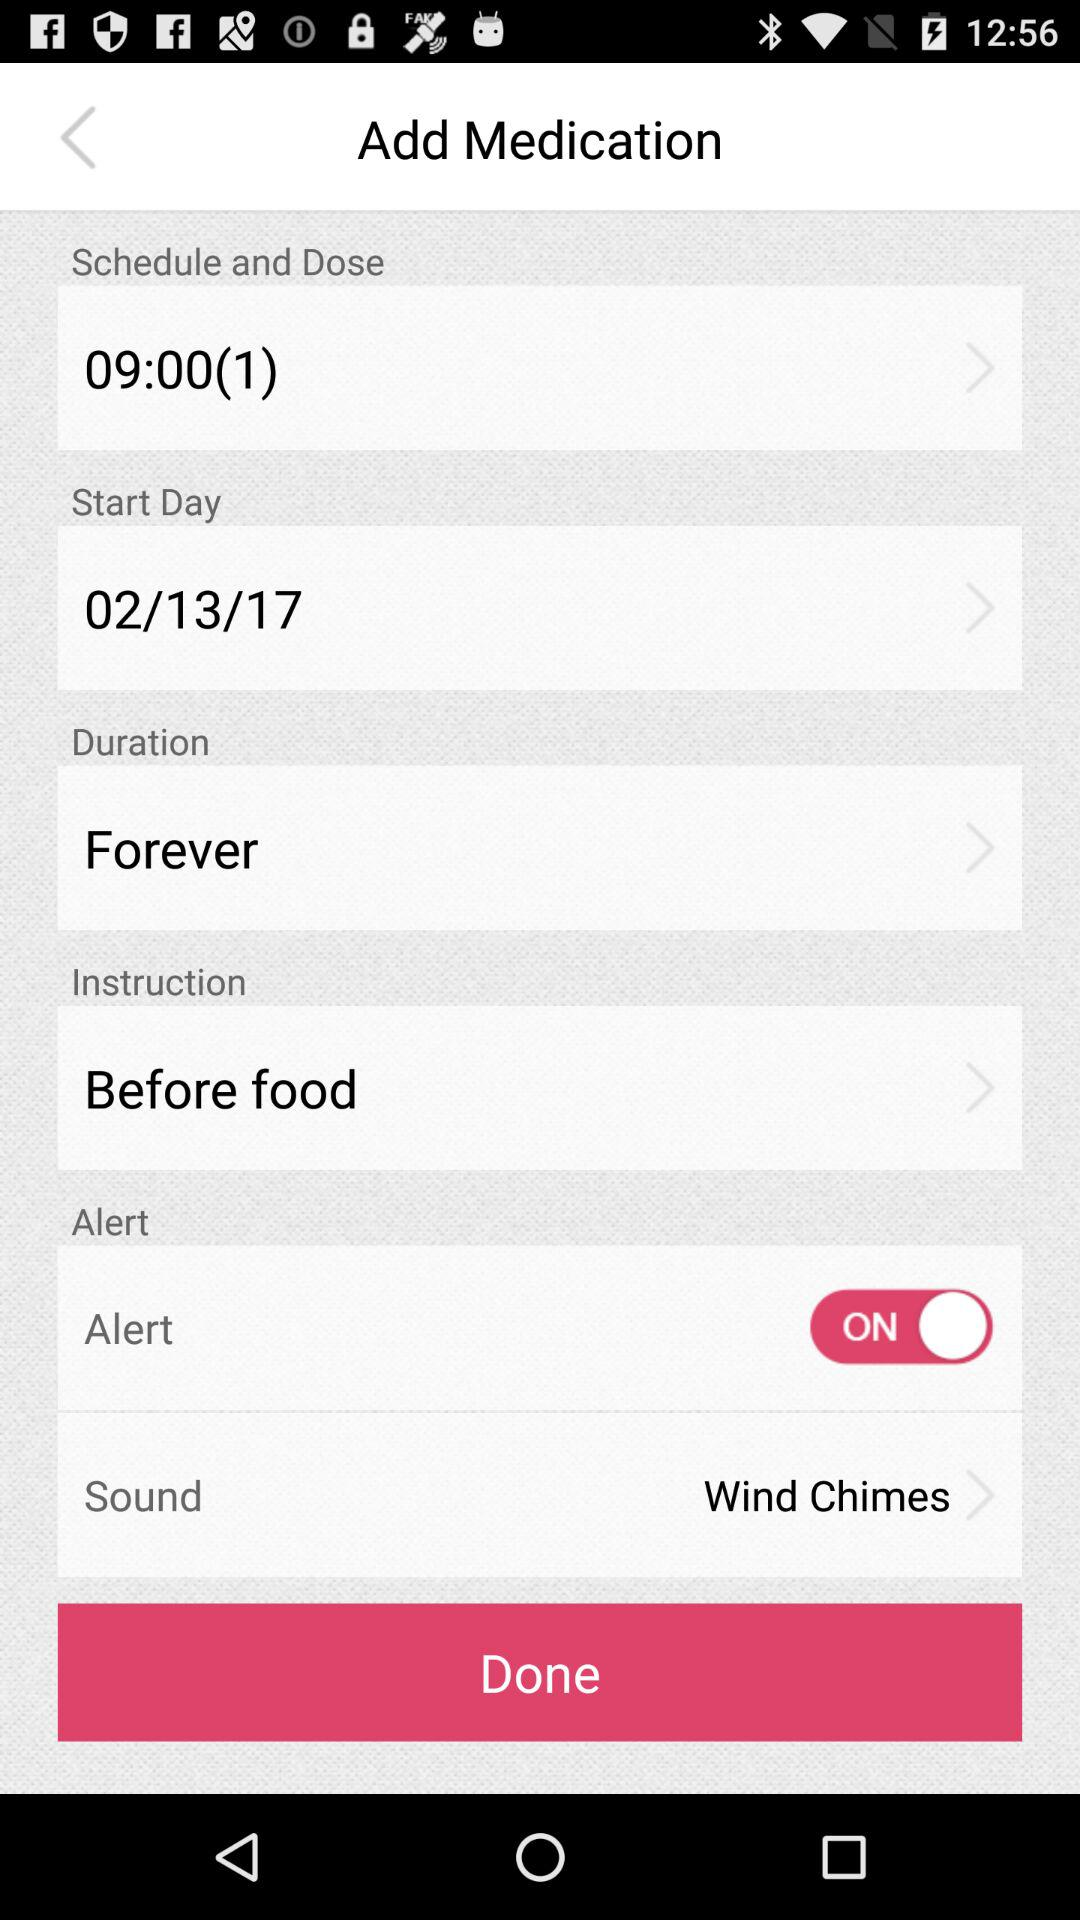What is the status of "Alert"? The status is "on". 